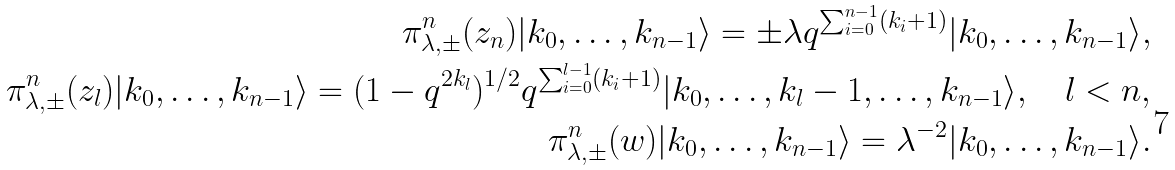Convert formula to latex. <formula><loc_0><loc_0><loc_500><loc_500>\pi _ { \lambda , \pm } ^ { n } ( z _ { n } ) | k _ { 0 } , \dots , k _ { n - 1 } \rangle = \pm \lambda q ^ { \sum _ { i = 0 } ^ { n - 1 } ( k _ { i } + 1 ) } | k _ { 0 } , \dots , k _ { n - 1 } \rangle , \\ \pi _ { \lambda , \pm } ^ { n } ( z _ { l } ) | k _ { 0 } , \dots , k _ { n - 1 } \rangle = ( 1 - q ^ { 2 k _ { l } } ) ^ { 1 / 2 } q ^ { \sum _ { i = 0 } ^ { l - 1 } ( k _ { i } + 1 ) } | k _ { 0 } , \dots , k _ { l } - 1 , \dots , k _ { n - 1 } \rangle , \quad l < n , \\ \pi _ { \lambda , \pm } ^ { n } ( w ) | k _ { 0 } , \dots , k _ { n - 1 } \rangle = \lambda ^ { - 2 } | k _ { 0 } , \dots , k _ { n - 1 } \rangle .</formula> 